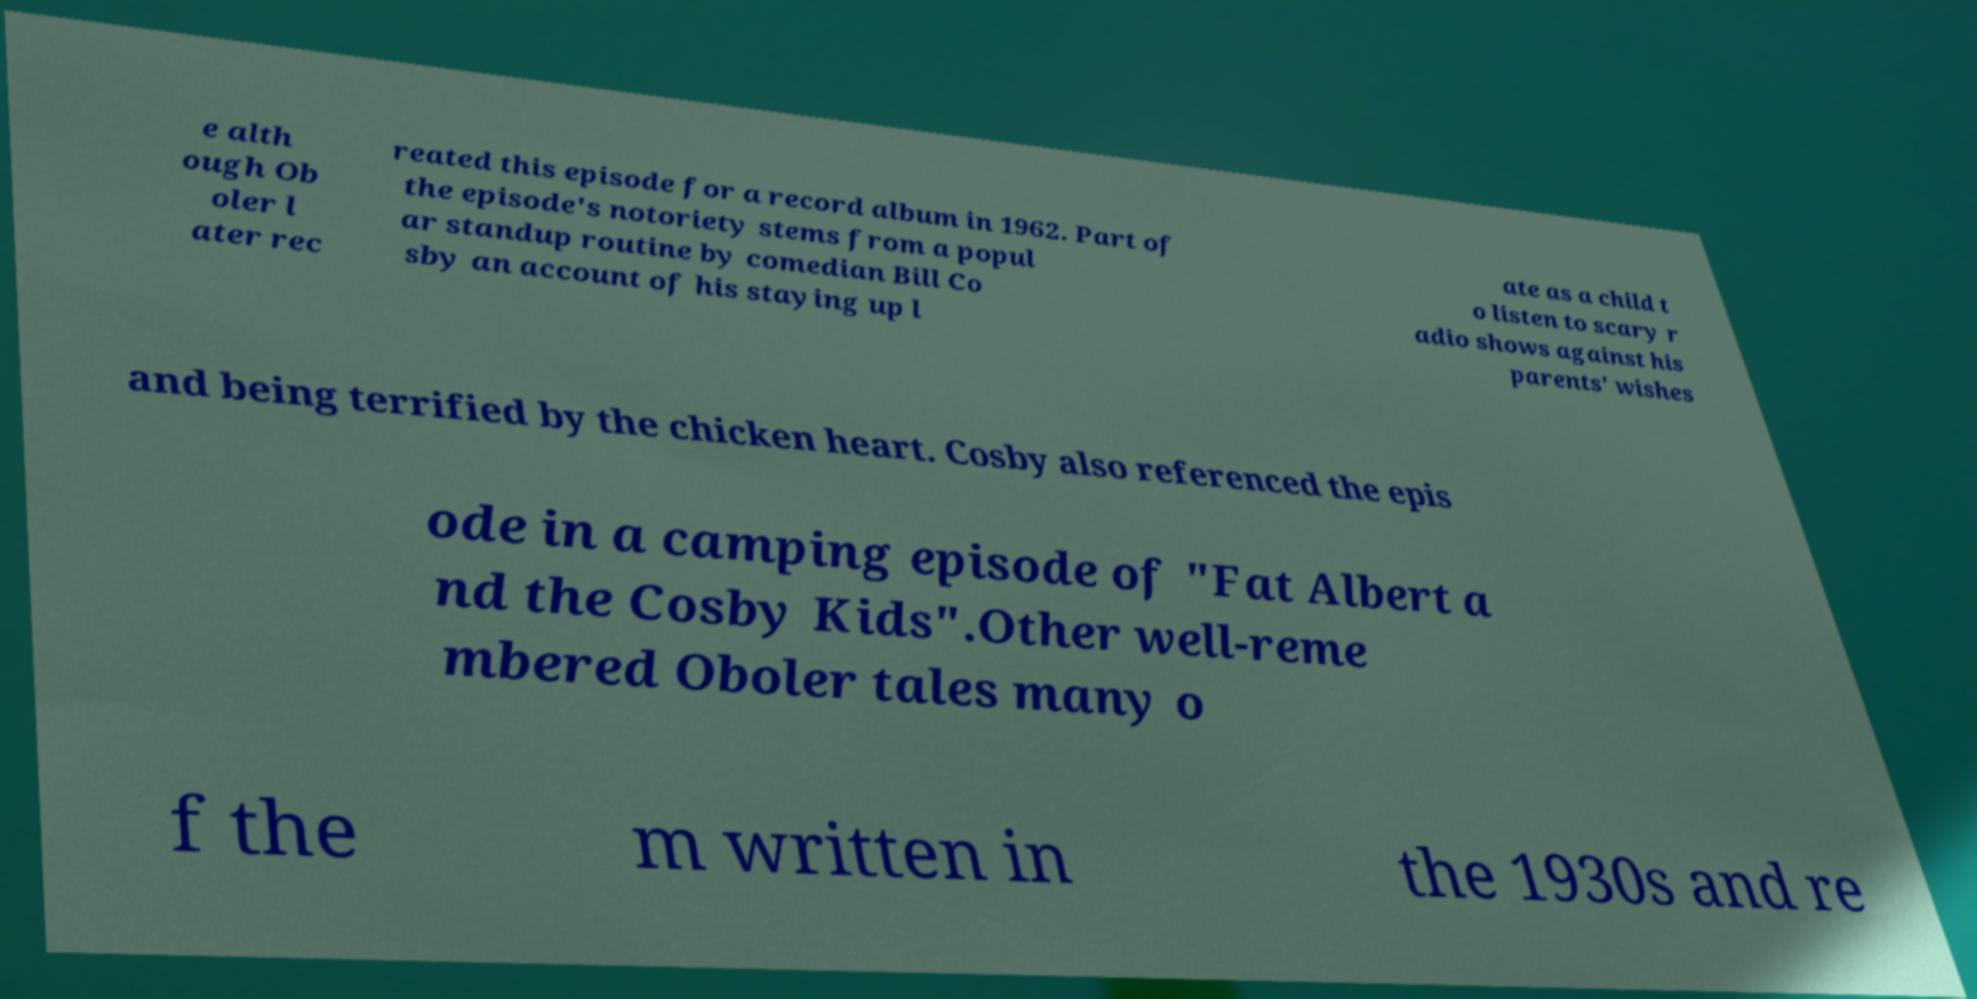Could you assist in decoding the text presented in this image and type it out clearly? e alth ough Ob oler l ater rec reated this episode for a record album in 1962. Part of the episode's notoriety stems from a popul ar standup routine by comedian Bill Co sby an account of his staying up l ate as a child t o listen to scary r adio shows against his parents' wishes and being terrified by the chicken heart. Cosby also referenced the epis ode in a camping episode of "Fat Albert a nd the Cosby Kids".Other well-reme mbered Oboler tales many o f the m written in the 1930s and re 